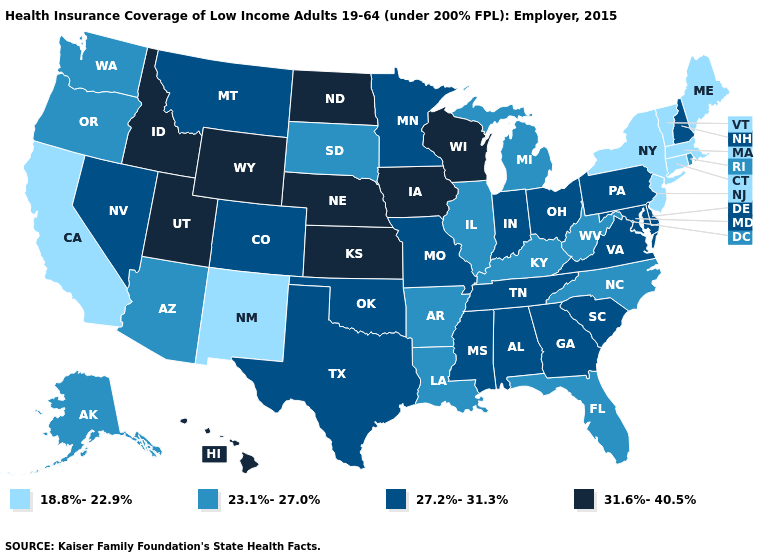Name the states that have a value in the range 31.6%-40.5%?
Be succinct. Hawaii, Idaho, Iowa, Kansas, Nebraska, North Dakota, Utah, Wisconsin, Wyoming. Name the states that have a value in the range 31.6%-40.5%?
Short answer required. Hawaii, Idaho, Iowa, Kansas, Nebraska, North Dakota, Utah, Wisconsin, Wyoming. Name the states that have a value in the range 23.1%-27.0%?
Concise answer only. Alaska, Arizona, Arkansas, Florida, Illinois, Kentucky, Louisiana, Michigan, North Carolina, Oregon, Rhode Island, South Dakota, Washington, West Virginia. Name the states that have a value in the range 18.8%-22.9%?
Be succinct. California, Connecticut, Maine, Massachusetts, New Jersey, New Mexico, New York, Vermont. What is the value of Pennsylvania?
Concise answer only. 27.2%-31.3%. Does Kansas have a higher value than Maryland?
Write a very short answer. Yes. Name the states that have a value in the range 27.2%-31.3%?
Answer briefly. Alabama, Colorado, Delaware, Georgia, Indiana, Maryland, Minnesota, Mississippi, Missouri, Montana, Nevada, New Hampshire, Ohio, Oklahoma, Pennsylvania, South Carolina, Tennessee, Texas, Virginia. Among the states that border South Carolina , which have the highest value?
Give a very brief answer. Georgia. What is the value of Iowa?
Short answer required. 31.6%-40.5%. Does Arizona have a lower value than Illinois?
Be succinct. No. Name the states that have a value in the range 27.2%-31.3%?
Concise answer only. Alabama, Colorado, Delaware, Georgia, Indiana, Maryland, Minnesota, Mississippi, Missouri, Montana, Nevada, New Hampshire, Ohio, Oklahoma, Pennsylvania, South Carolina, Tennessee, Texas, Virginia. What is the value of Iowa?
Write a very short answer. 31.6%-40.5%. Does Kentucky have the highest value in the South?
Short answer required. No. Name the states that have a value in the range 27.2%-31.3%?
Short answer required. Alabama, Colorado, Delaware, Georgia, Indiana, Maryland, Minnesota, Mississippi, Missouri, Montana, Nevada, New Hampshire, Ohio, Oklahoma, Pennsylvania, South Carolina, Tennessee, Texas, Virginia. Does South Dakota have the highest value in the MidWest?
Short answer required. No. 